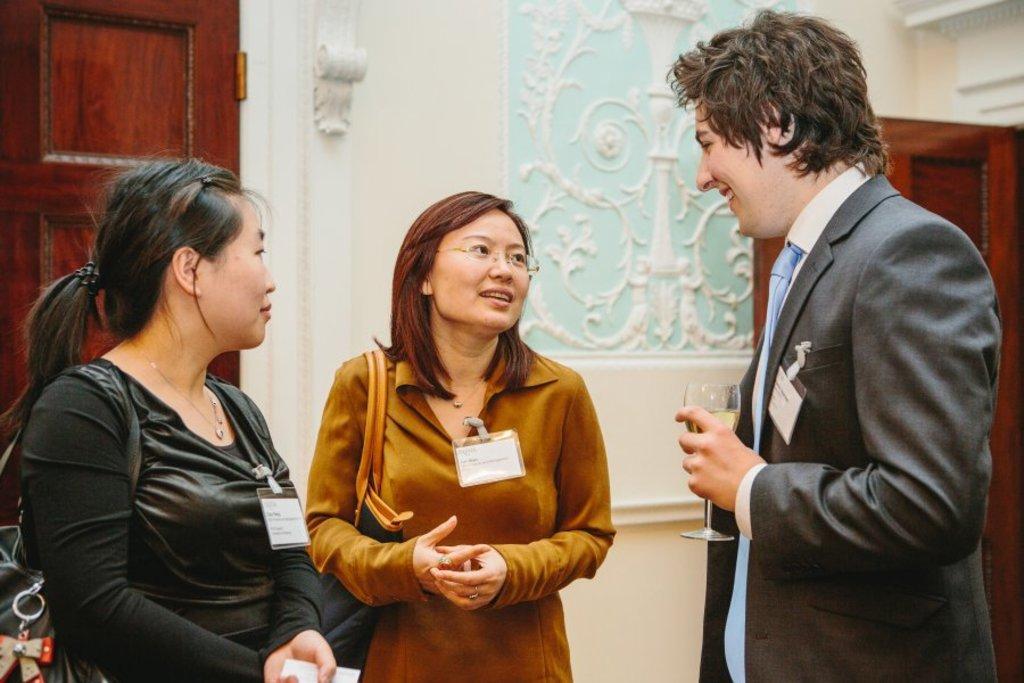Describe this image in one or two sentences. In this image there are two women and a man, man is holding a glass in hand, in the background there is a wall, for that wall there are doors. 